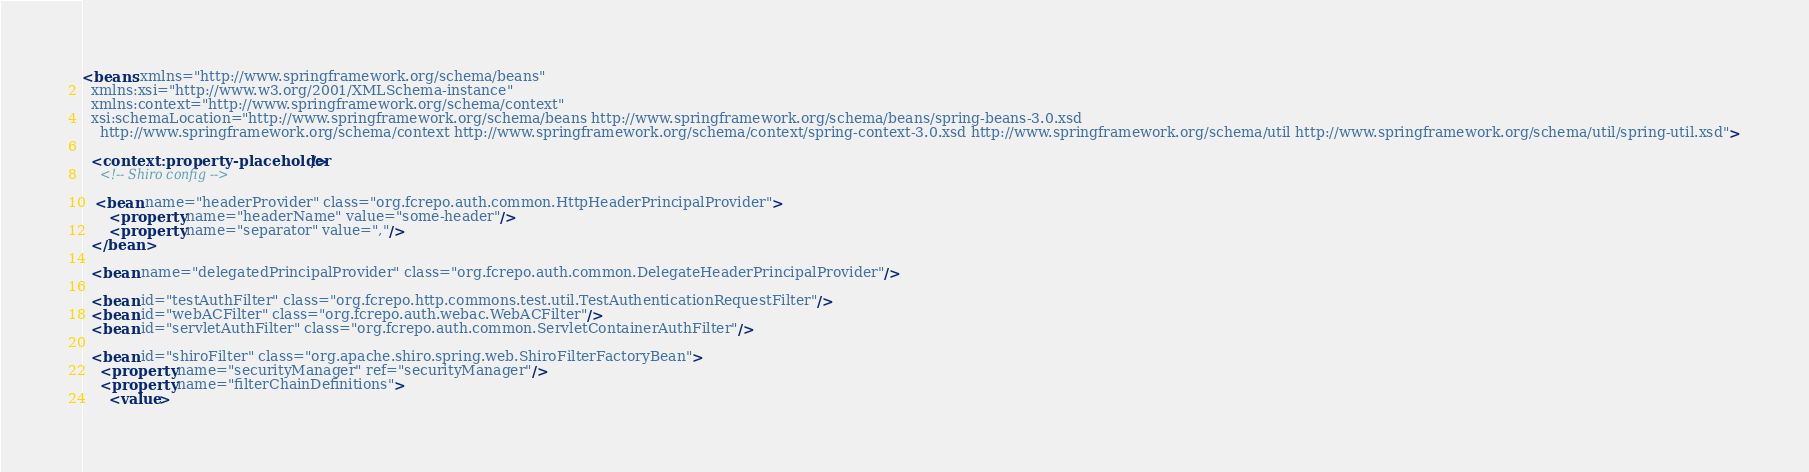<code> <loc_0><loc_0><loc_500><loc_500><_XML_><beans xmlns="http://www.springframework.org/schema/beans"
  xmlns:xsi="http://www.w3.org/2001/XMLSchema-instance"
  xmlns:context="http://www.springframework.org/schema/context"
  xsi:schemaLocation="http://www.springframework.org/schema/beans http://www.springframework.org/schema/beans/spring-beans-3.0.xsd
    http://www.springframework.org/schema/context http://www.springframework.org/schema/context/spring-context-3.0.xsd http://www.springframework.org/schema/util http://www.springframework.org/schema/util/spring-util.xsd">
 
  <context:property-placeholder/>
    <!-- Shiro config -->

   <bean name="headerProvider" class="org.fcrepo.auth.common.HttpHeaderPrincipalProvider">
      <property name="headerName" value="some-header"/>
      <property name="separator" value=","/>
  </bean>

  <bean name="delegatedPrincipalProvider" class="org.fcrepo.auth.common.DelegateHeaderPrincipalProvider"/>
  
  <bean id="testAuthFilter" class="org.fcrepo.http.commons.test.util.TestAuthenticationRequestFilter"/>
  <bean id="webACFilter" class="org.fcrepo.auth.webac.WebACFilter"/>
  <bean id="servletAuthFilter" class="org.fcrepo.auth.common.ServletContainerAuthFilter"/>
  
  <bean id="shiroFilter" class="org.apache.shiro.spring.web.ShiroFilterFactoryBean">
    <property name="securityManager" ref="securityManager"/>
    <property name="filterChainDefinitions">
      <value></code> 